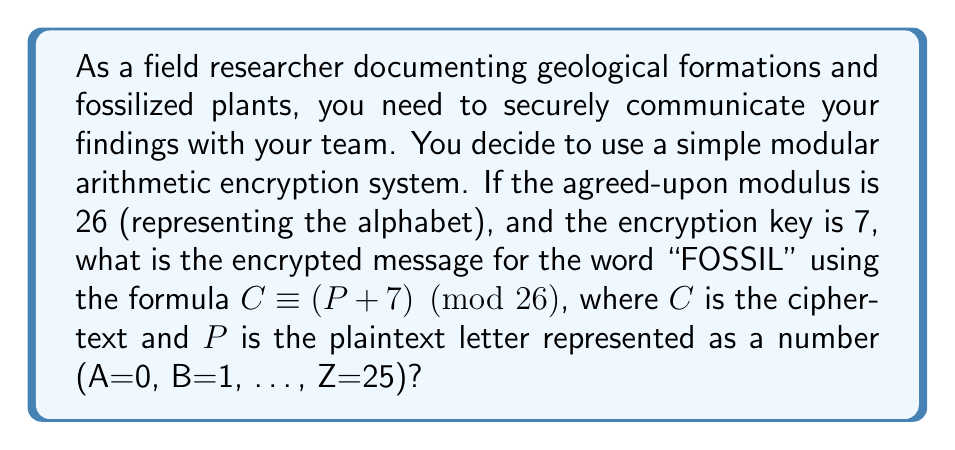Could you help me with this problem? Let's encrypt the word "FOSSIL" letter by letter:

1. F: In the alphabet, F is the 5th letter (starting from 0).
   $C \equiv (5 + 7) \pmod{26} \equiv 12 \pmod{26}$
   12 corresponds to M

2. O: O is the 14th letter.
   $C \equiv (14 + 7) \pmod{26} \equiv 21 \pmod{26}$
   21 corresponds to V

3. S: S is the 18th letter.
   $C \equiv (18 + 7) \pmod{26} \equiv 25 \pmod{26}$
   25 corresponds to Z

4. S: S is the 18th letter (same as previous).
   $C \equiv (18 + 7) \pmod{26} \equiv 25 \pmod{26}$
   25 corresponds to Z

5. I: I is the 8th letter.
   $C \equiv (8 + 7) \pmod{26} \equiv 15 \pmod{26}$
   15 corresponds to P

6. L: L is the 11th letter.
   $C \equiv (11 + 7) \pmod{26} \equiv 18 \pmod{26}$
   18 corresponds to S

Therefore, the encrypted message is MVZZPS.
Answer: MVZZPS 